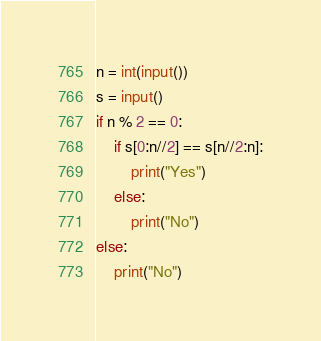Convert code to text. <code><loc_0><loc_0><loc_500><loc_500><_Python_>n = int(input())
s = input()
if n % 2 == 0:
    if s[0:n//2] == s[n//2:n]:
        print("Yes")
    else:
        print("No")
else:
    print("No")</code> 